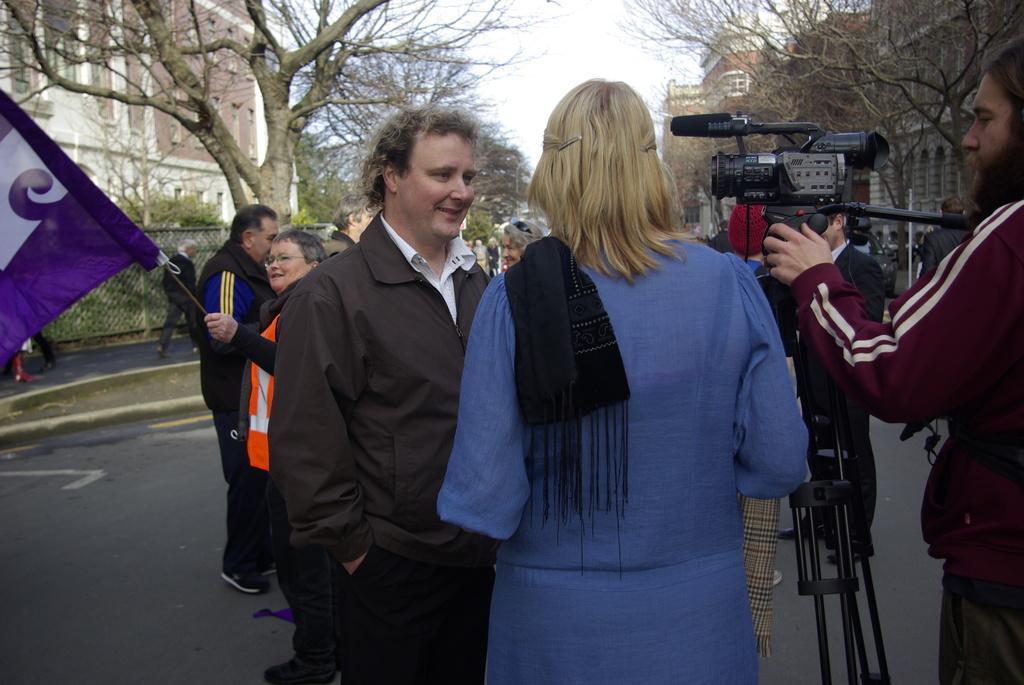Could you give a brief overview of what you see in this image? In this image I can see number of people are standing and on the left side I can see one of them is holding a flag. On the right side of this image I can see a tripod stand and on it I can see a camera. In the background I can see number of trees, number of buildings and the sky. 